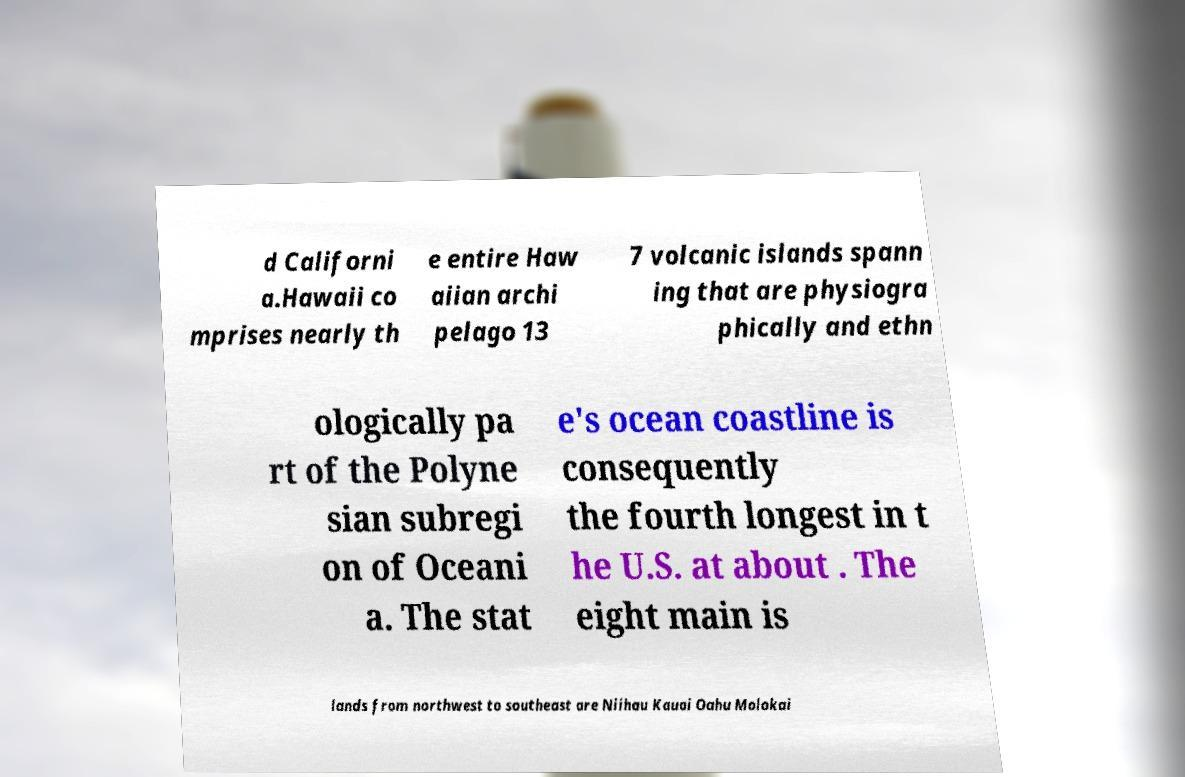Could you assist in decoding the text presented in this image and type it out clearly? d Californi a.Hawaii co mprises nearly th e entire Haw aiian archi pelago 13 7 volcanic islands spann ing that are physiogra phically and ethn ologically pa rt of the Polyne sian subregi on of Oceani a. The stat e's ocean coastline is consequently the fourth longest in t he U.S. at about . The eight main is lands from northwest to southeast are Niihau Kauai Oahu Molokai 